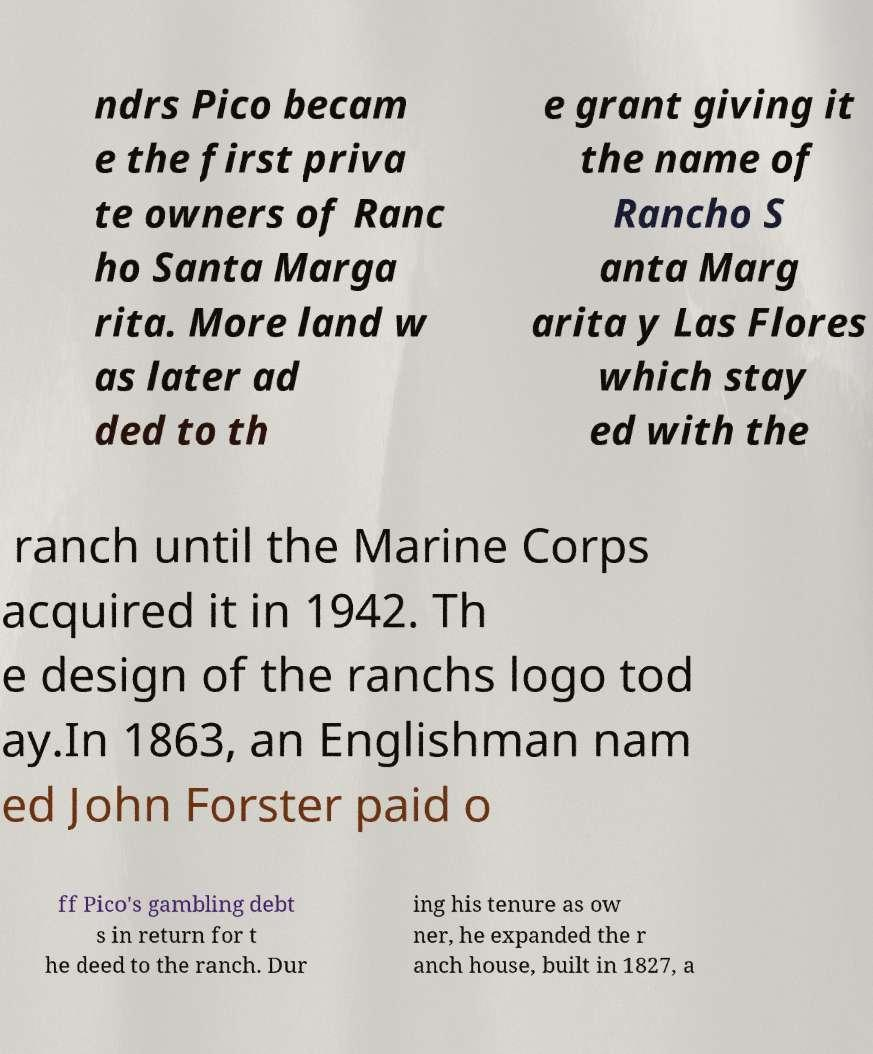I need the written content from this picture converted into text. Can you do that? ndrs Pico becam e the first priva te owners of Ranc ho Santa Marga rita. More land w as later ad ded to th e grant giving it the name of Rancho S anta Marg arita y Las Flores which stay ed with the ranch until the Marine Corps acquired it in 1942. Th e design of the ranchs logo tod ay.In 1863, an Englishman nam ed John Forster paid o ff Pico's gambling debt s in return for t he deed to the ranch. Dur ing his tenure as ow ner, he expanded the r anch house, built in 1827, a 